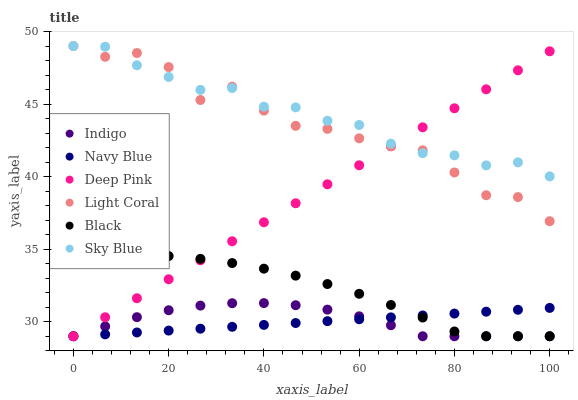Does Navy Blue have the minimum area under the curve?
Answer yes or no. Yes. Does Sky Blue have the maximum area under the curve?
Answer yes or no. Yes. Does Indigo have the minimum area under the curve?
Answer yes or no. No. Does Indigo have the maximum area under the curve?
Answer yes or no. No. Is Navy Blue the smoothest?
Answer yes or no. Yes. Is Light Coral the roughest?
Answer yes or no. Yes. Is Indigo the smoothest?
Answer yes or no. No. Is Indigo the roughest?
Answer yes or no. No. Does Deep Pink have the lowest value?
Answer yes or no. Yes. Does Light Coral have the lowest value?
Answer yes or no. No. Does Sky Blue have the highest value?
Answer yes or no. Yes. Does Indigo have the highest value?
Answer yes or no. No. Is Navy Blue less than Sky Blue?
Answer yes or no. Yes. Is Sky Blue greater than Indigo?
Answer yes or no. Yes. Does Black intersect Indigo?
Answer yes or no. Yes. Is Black less than Indigo?
Answer yes or no. No. Is Black greater than Indigo?
Answer yes or no. No. Does Navy Blue intersect Sky Blue?
Answer yes or no. No. 